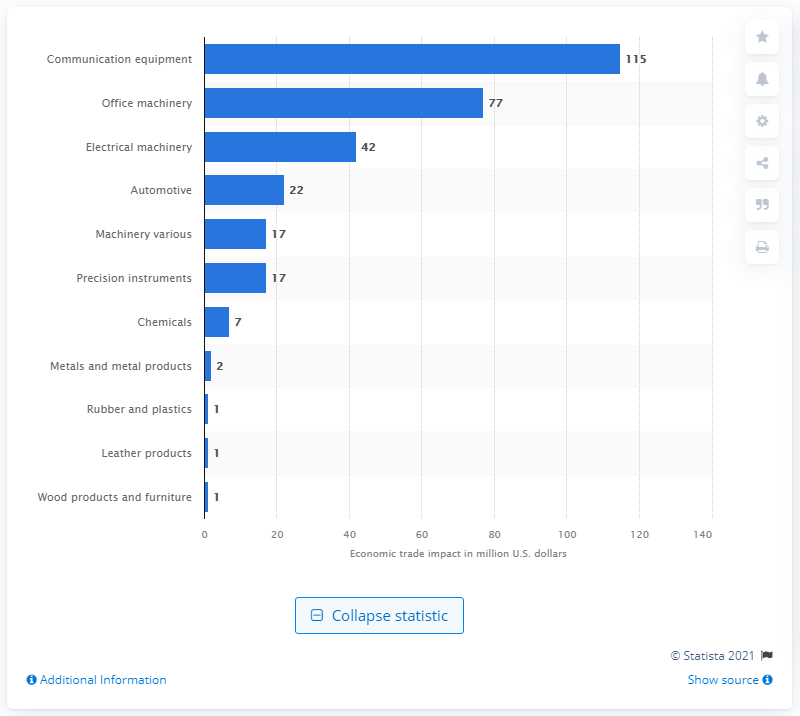Draw attention to some important aspects in this diagram. The Philippine communication equipment industry is expected to lose approximately $115 million due to a two percent reduction in China's exports of intermediate inputs. 